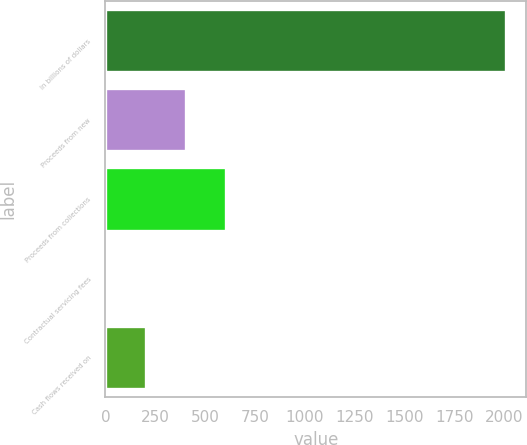<chart> <loc_0><loc_0><loc_500><loc_500><bar_chart><fcel>In billions of dollars<fcel>Proceeds from new<fcel>Proceeds from collections<fcel>Contractual servicing fees<fcel>Cash flows received on<nl><fcel>2009<fcel>402.36<fcel>603.19<fcel>0.7<fcel>201.53<nl></chart> 